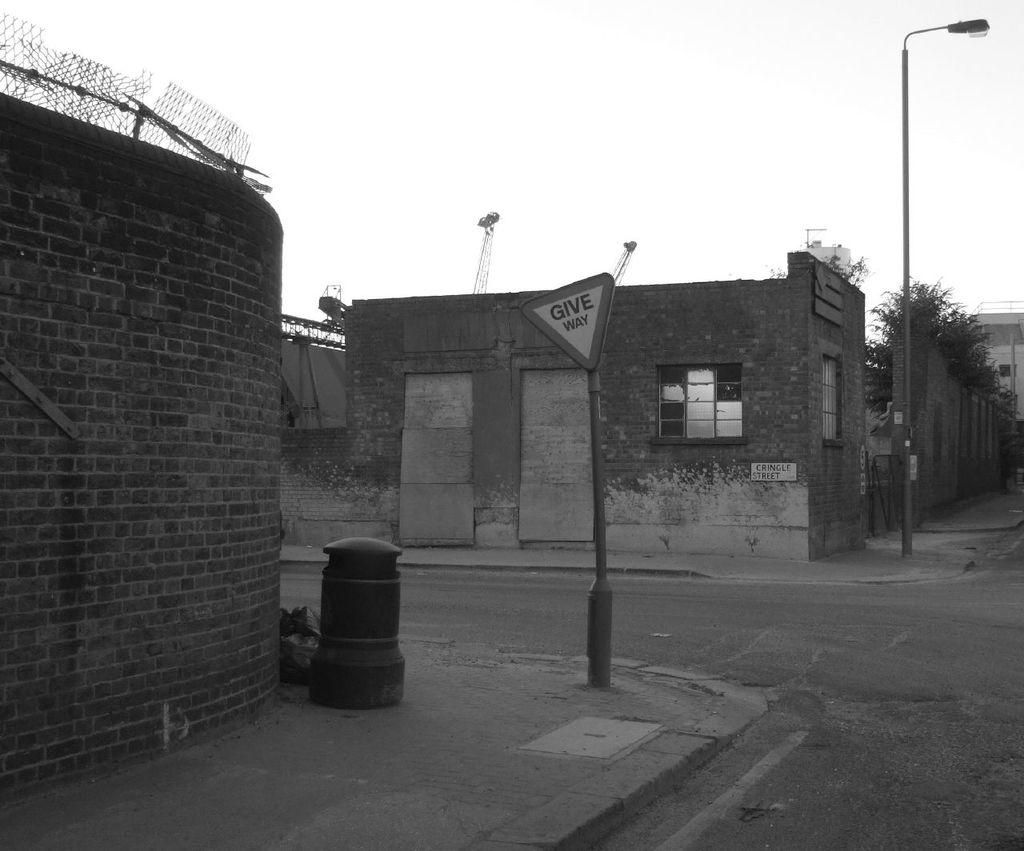What type of pathway is visible in the image? There is a road in the image. What structures can be seen along the road? There are poles and buildings with windows in the image. What type of vegetation is present in the image? There are trees in the image. What can be seen in the background of the image? The sky is visible in the background of the image. What advice is given by the trees in the image? There is no advice given by the trees in the image; they are simply trees. 